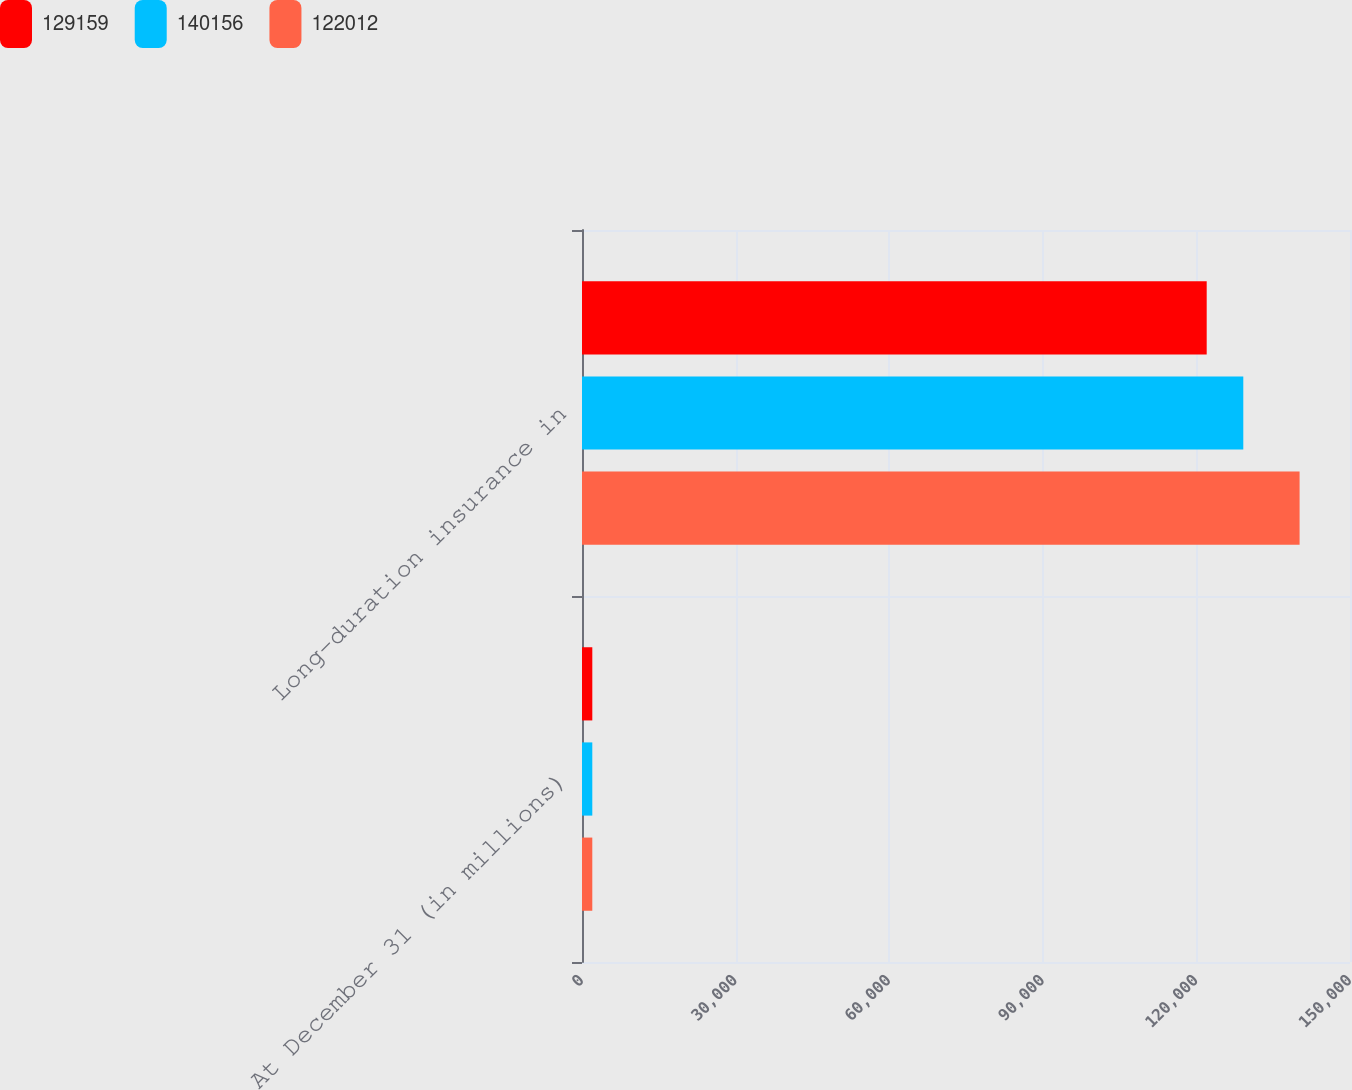Convert chart to OTSL. <chart><loc_0><loc_0><loc_500><loc_500><stacked_bar_chart><ecel><fcel>At December 31 (in millions)<fcel>Long-duration insurance in<nl><fcel>129159<fcel>2013<fcel>122012<nl><fcel>140156<fcel>2012<fcel>129159<nl><fcel>122012<fcel>2011<fcel>140156<nl></chart> 